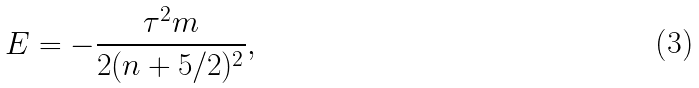Convert formula to latex. <formula><loc_0><loc_0><loc_500><loc_500>E = - \frac { { { \tau } ^ { 2 } } m } { 2 ( n + 5 / 2 ) ^ { 2 } } ,</formula> 